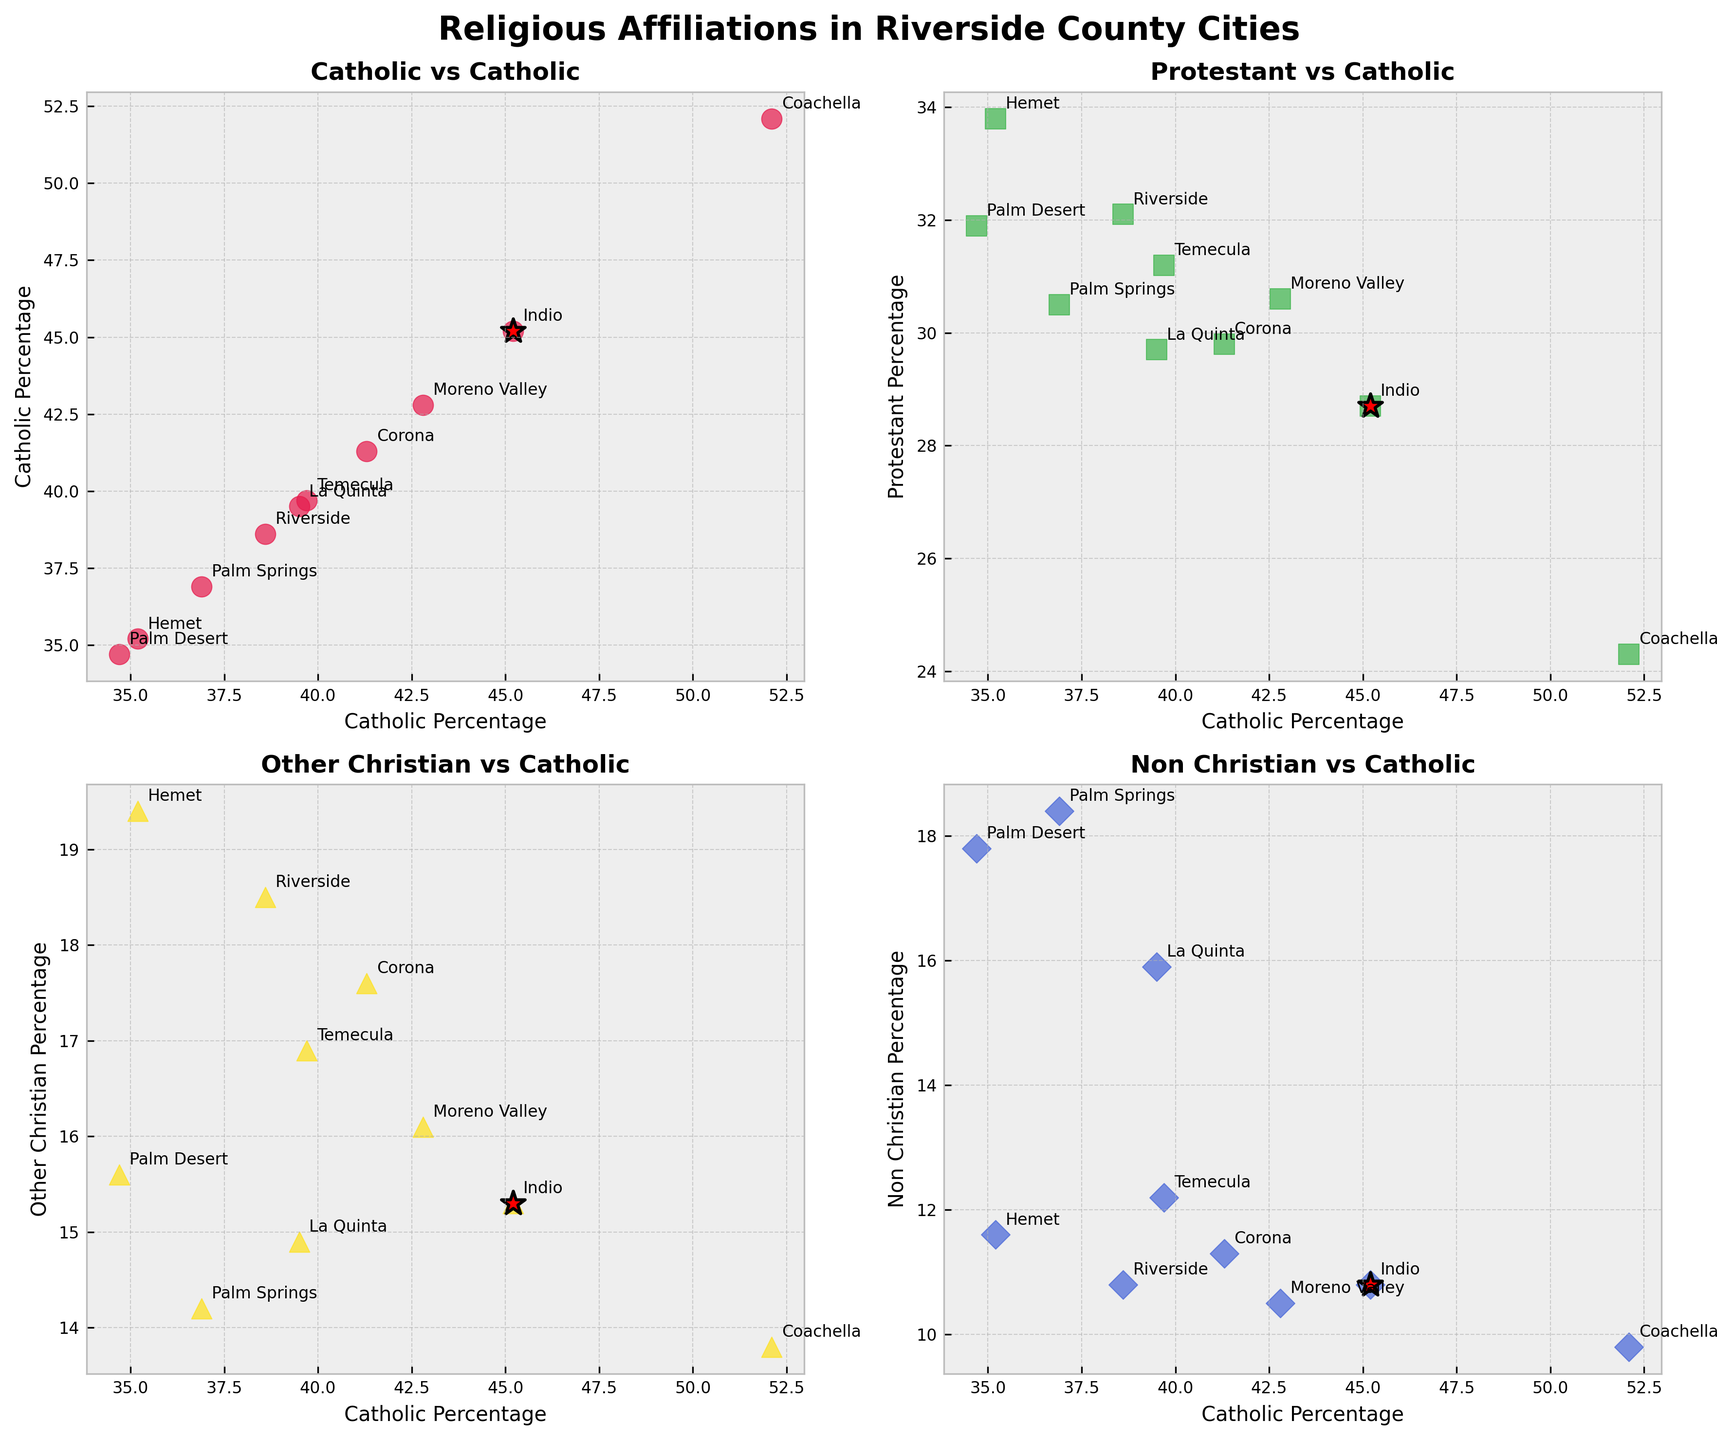What is the title of the figure? The title of the figure is located at the top center and summarizes the content of the plots.
Answer: Religious Affiliations in Riverside County Cities Which city has the highest percentage of Catholics? By looking at the scatter points and annotations, identify the city with the highest percentage on the x-axis labeled 'Catholic Percentage'.
Answer: Coachella In the Catholic vs Protestant plot, which city has a higher Protestant percentage than Catholic percentage? Find the scatter point above the 45-degree line (where x = y) in the Catholic vs Protestant subplot.
Answer: Hemet How does Indio's percentage of Non-Christian affiliation compare to Palm Springs? Compare the y-coordinates of Indio and Palm Springs in the subplot comparing Catholic and Non-Christian percentages.
Answer: Indio has a lower percentage of Non-Christian affiliation than Palm Springs What is the visual cue used to highlight Indio in the plots? Look for the specific styling element used to emphasize Indio's data points in each subplot.
Answer: Red star with black edge Which city has the lowest percentage of Catholics among the plotted data? Identify the scatter point with the lowest x-coordinate in any of the subplots.
Answer: Palm Desert Is there any city with an equal percentage of Catholics and Non-Christians? Check in the Catholic vs Non-Christian subplot for data points located on the 45-degree line where x equals y.
Answer: None Which city shows the smallest difference between Catholic and Protestant percentages? Find the data points in the Catholic vs Protestant subplot where the vertical distance from the 45-degree equality line is minimal.
Answer: Moreno Valley Does Palm Desert have a higher or lower percentage of Other_Christian affiliations compared to Indio? Compare the y-coordinates of Palm Desert and Indio in the subplot comparing Catholic and Other_Christian percentages.
Answer: Lower How does the spread of Protestant percentages vary across cities? Observe the range of y-coordinates of the scatter points in the subplot comparing Catholic and Protestant percentages.
Answer: Varies widely 